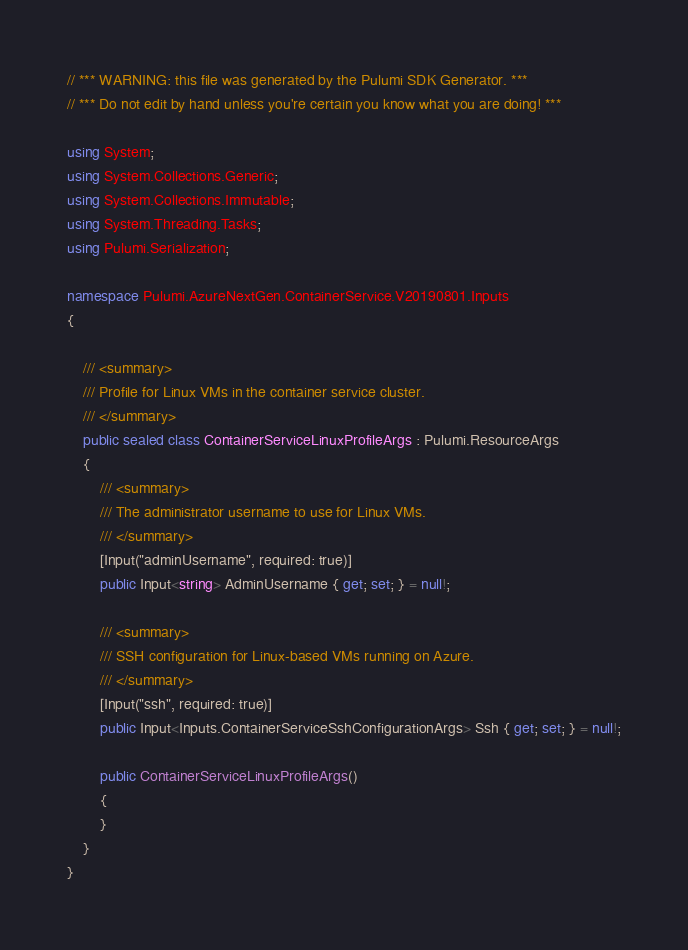Convert code to text. <code><loc_0><loc_0><loc_500><loc_500><_C#_>// *** WARNING: this file was generated by the Pulumi SDK Generator. ***
// *** Do not edit by hand unless you're certain you know what you are doing! ***

using System;
using System.Collections.Generic;
using System.Collections.Immutable;
using System.Threading.Tasks;
using Pulumi.Serialization;

namespace Pulumi.AzureNextGen.ContainerService.V20190801.Inputs
{

    /// <summary>
    /// Profile for Linux VMs in the container service cluster.
    /// </summary>
    public sealed class ContainerServiceLinuxProfileArgs : Pulumi.ResourceArgs
    {
        /// <summary>
        /// The administrator username to use for Linux VMs.
        /// </summary>
        [Input("adminUsername", required: true)]
        public Input<string> AdminUsername { get; set; } = null!;

        /// <summary>
        /// SSH configuration for Linux-based VMs running on Azure.
        /// </summary>
        [Input("ssh", required: true)]
        public Input<Inputs.ContainerServiceSshConfigurationArgs> Ssh { get; set; } = null!;

        public ContainerServiceLinuxProfileArgs()
        {
        }
    }
}
</code> 